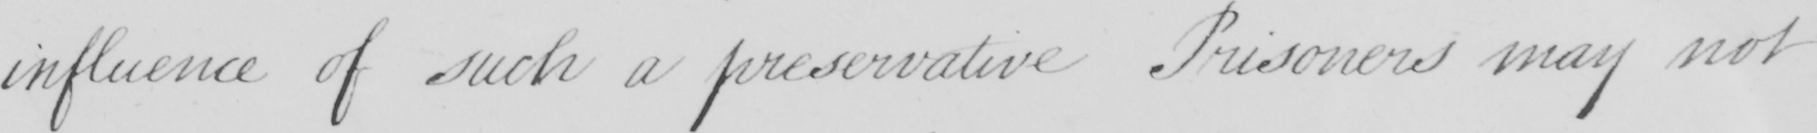What is written in this line of handwriting? influence of such a preservative Prisoners may not 